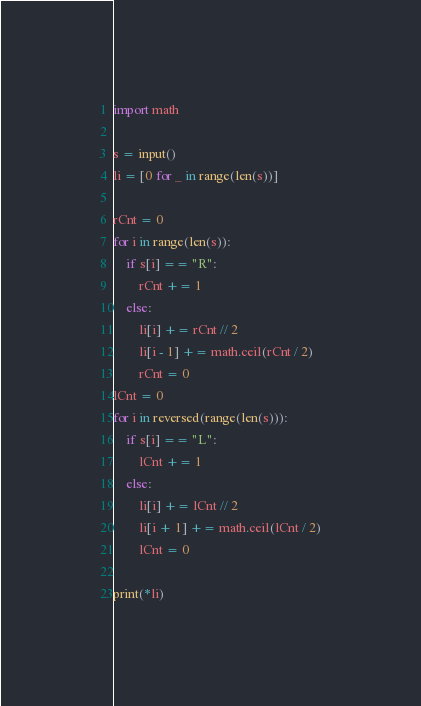Convert code to text. <code><loc_0><loc_0><loc_500><loc_500><_Python_>import math

s = input()
li = [0 for _ in range(len(s))]

rCnt = 0
for i in range(len(s)):
    if s[i] == "R":
        rCnt += 1
    else:
        li[i] += rCnt // 2
        li[i - 1] += math.ceil(rCnt / 2)
        rCnt = 0
lCnt = 0
for i in reversed(range(len(s))):
    if s[i] == "L":
        lCnt += 1
    else:
        li[i] += lCnt // 2
        li[i + 1] += math.ceil(lCnt / 2)
        lCnt = 0

print(*li)</code> 